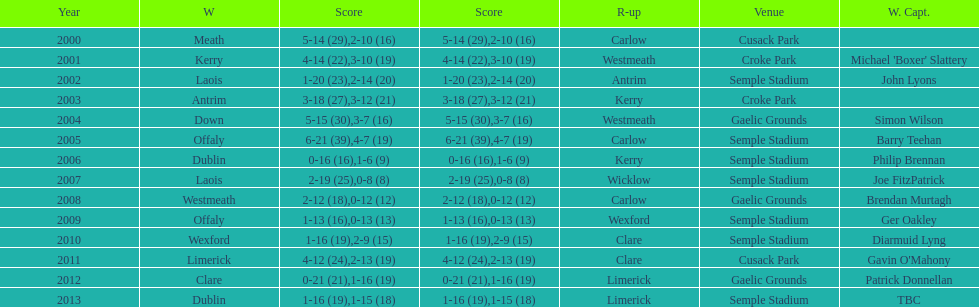How many times was carlow the runner-up? 3. 